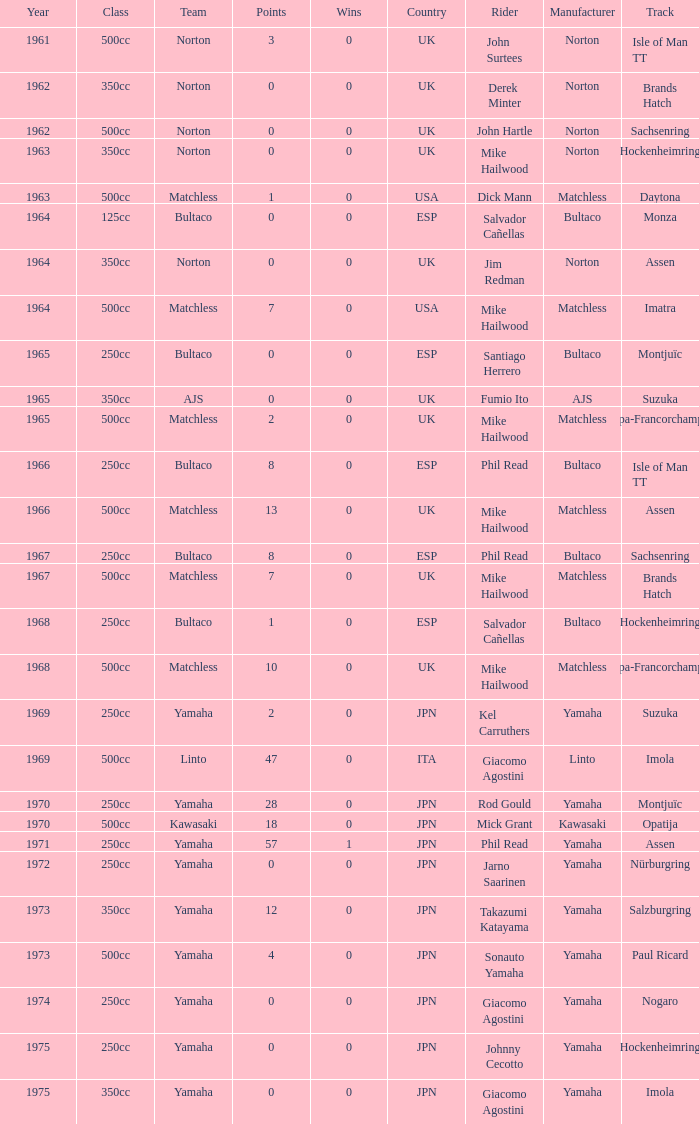Which class corresponds to more than 2 points, wins greater than 0, and a year earlier than 1973? 250cc. 